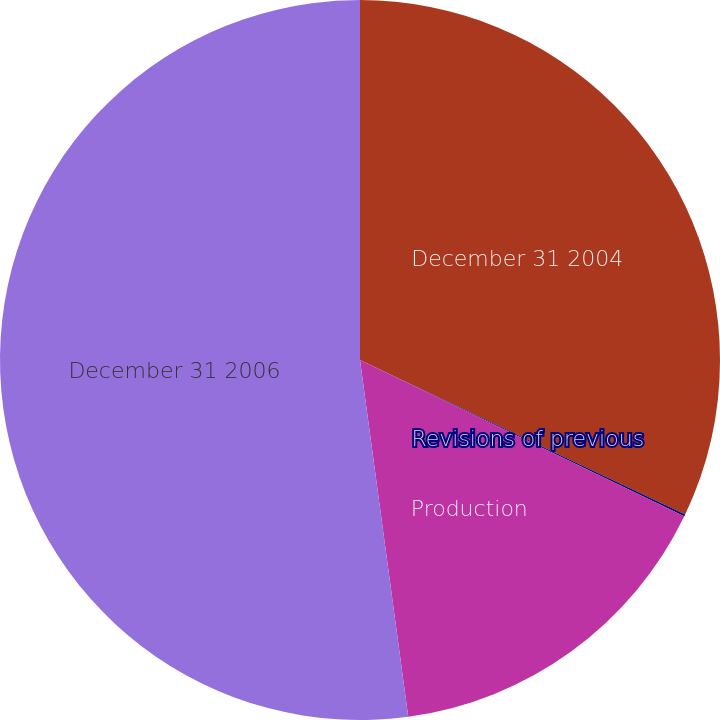<chart> <loc_0><loc_0><loc_500><loc_500><pie_chart><fcel>December 31 2004<fcel>Revisions of previous<fcel>Production<fcel>December 31 2006<nl><fcel>32.06%<fcel>0.09%<fcel>15.71%<fcel>52.14%<nl></chart> 